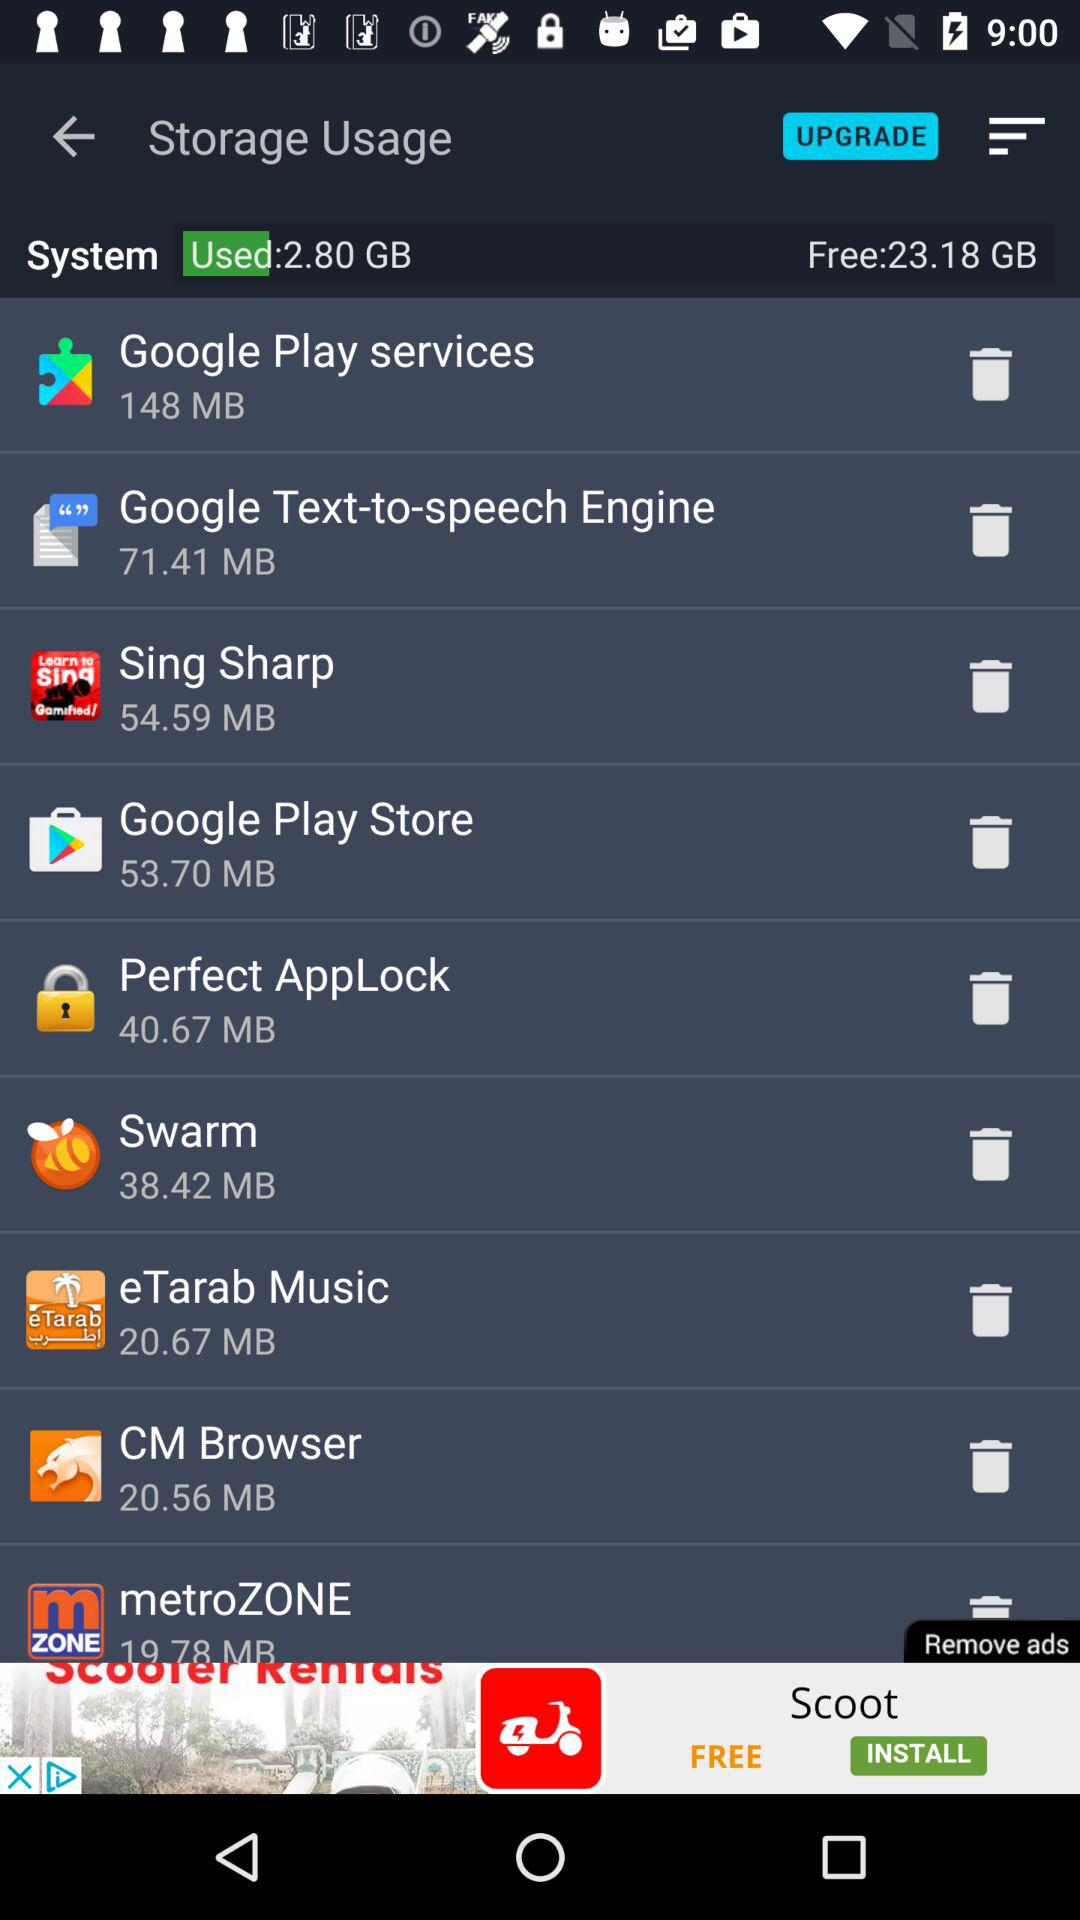How many GB of memory is used in the system? In the system, 2.80 GB of memory is used. 